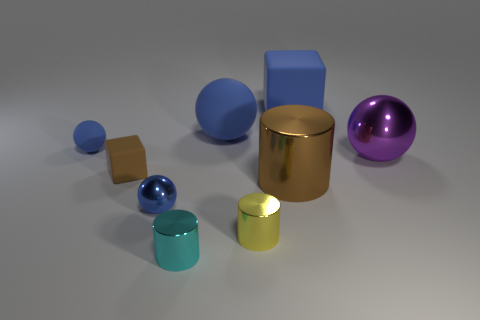Subtract all red cylinders. How many blue balls are left? 3 Subtract all large metal balls. How many balls are left? 3 Subtract 2 spheres. How many spheres are left? 2 Subtract all blue cubes. How many cubes are left? 1 Subtract all blocks. How many objects are left? 7 Subtract 0 green blocks. How many objects are left? 9 Subtract all red blocks. Subtract all purple cylinders. How many blocks are left? 2 Subtract all large things. Subtract all small metallic spheres. How many objects are left? 4 Add 8 big purple spheres. How many big purple spheres are left? 9 Add 3 small yellow matte things. How many small yellow matte things exist? 3 